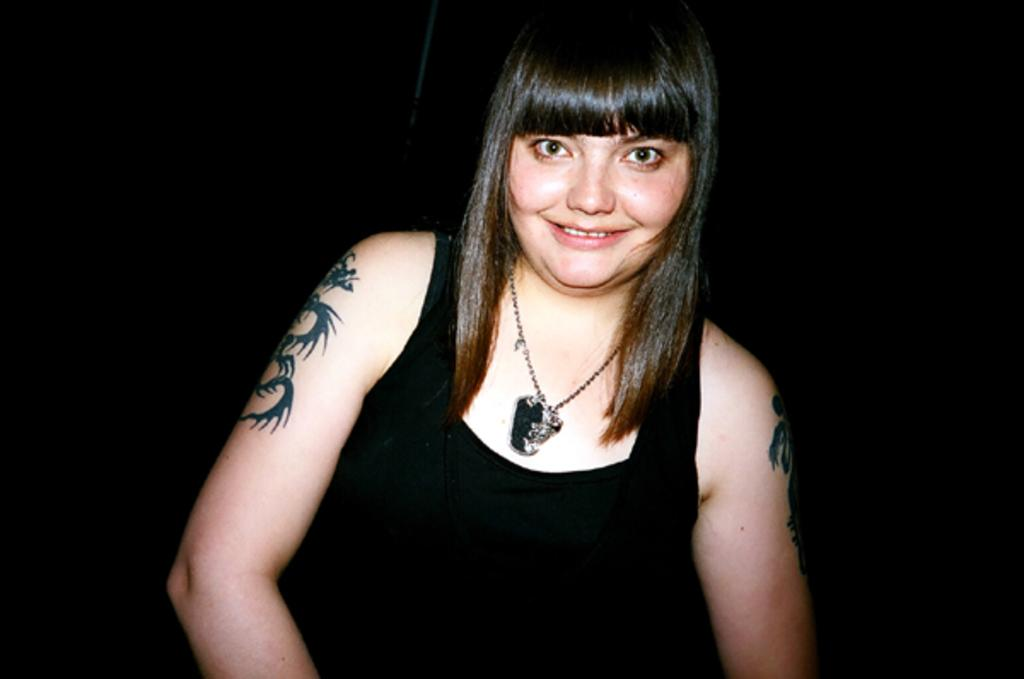Who is the main subject in the image? There is a lady in the image. What is the lady wearing? The lady is wearing a black dress. Are there any visible accessories on the lady? Yes, there is a chain around the lady's neck. Can you describe any additional features on the lady's body? The lady has tattoos on her hands. How many rings does the lady have on her fingers in the image? There is no mention of rings on the lady's fingers in the provided facts, so we cannot determine the number of rings from the image. 